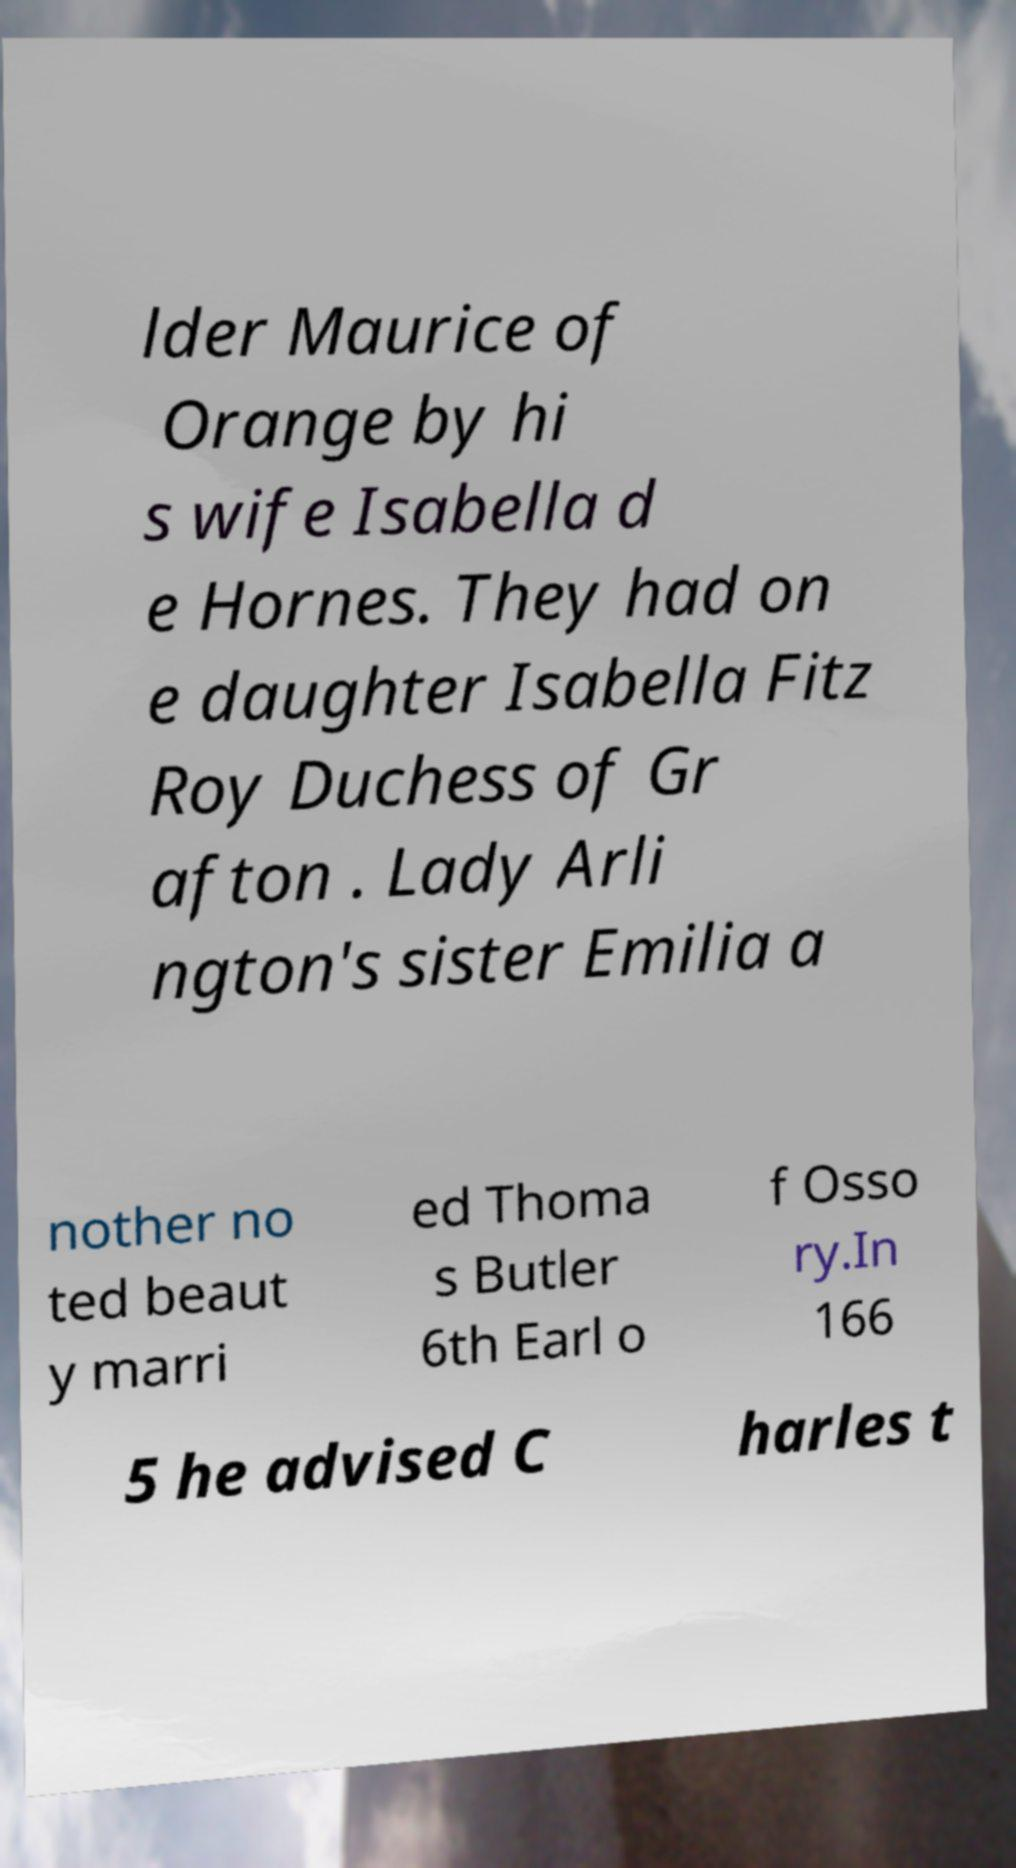There's text embedded in this image that I need extracted. Can you transcribe it verbatim? lder Maurice of Orange by hi s wife Isabella d e Hornes. They had on e daughter Isabella Fitz Roy Duchess of Gr afton . Lady Arli ngton's sister Emilia a nother no ted beaut y marri ed Thoma s Butler 6th Earl o f Osso ry.In 166 5 he advised C harles t 